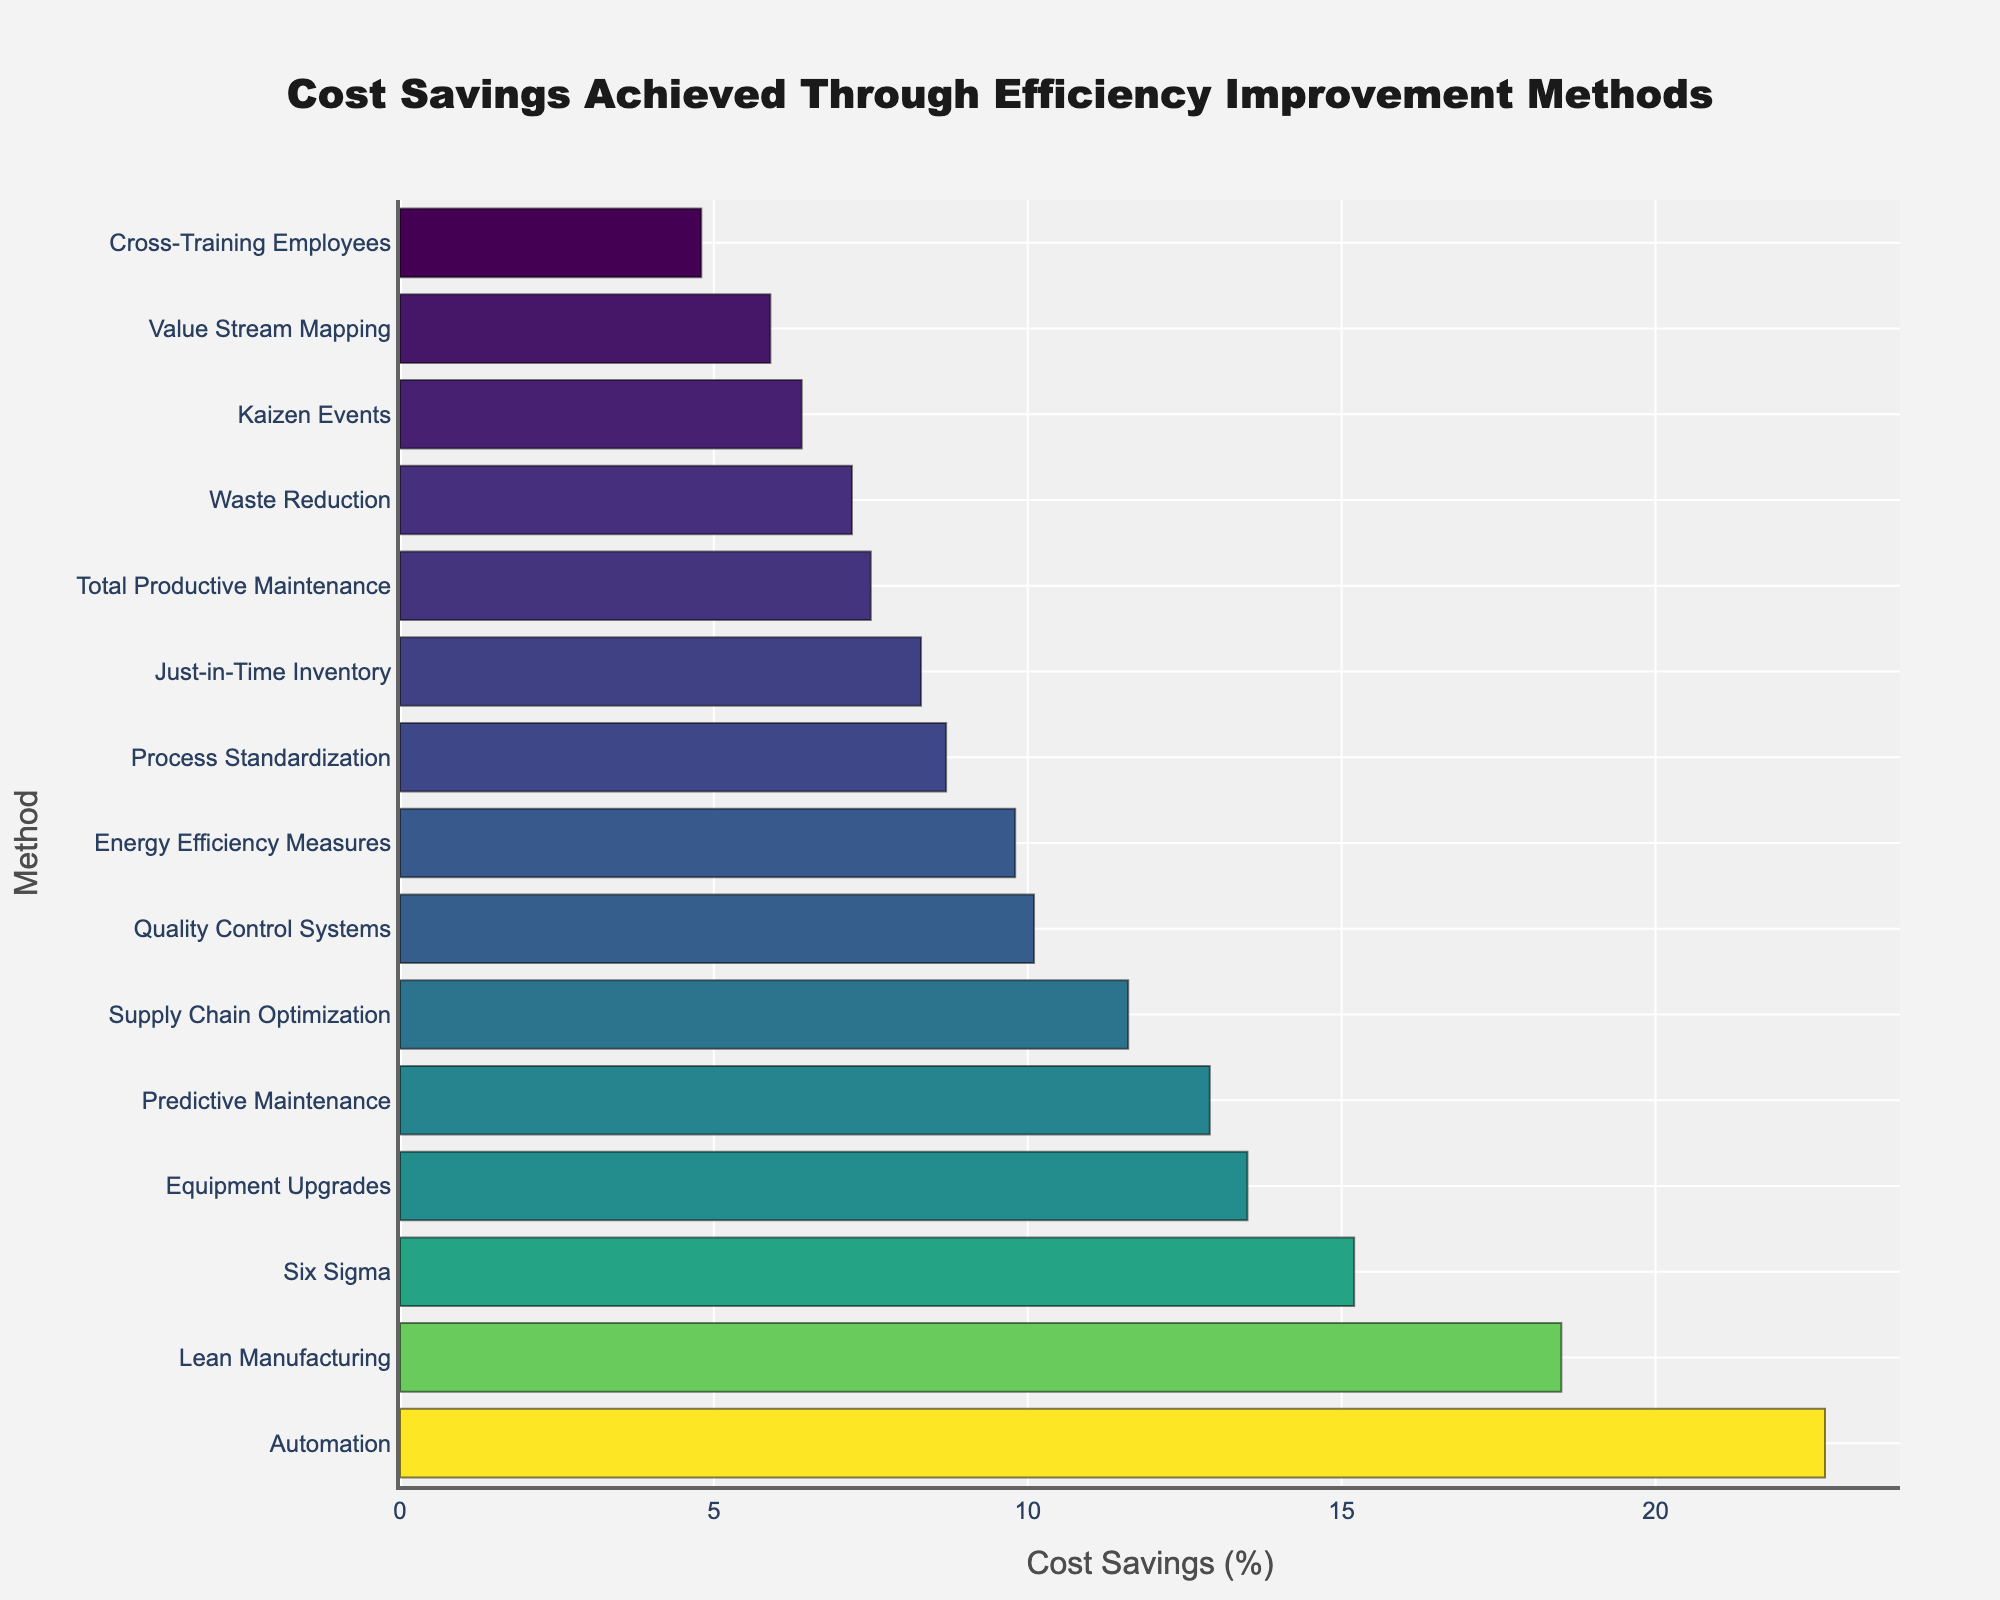Which method achieved the highest cost savings? The method that achieved the highest cost savings is the one with the longest bar in the chart, which is Automation with 22.7%.
Answer: Automation Which method achieved the lowest cost savings? The method that achieved the lowest cost savings is the one with the shortest bar in the chart, which is Cross-Training Employees with 4.8%.
Answer: Cross-Training Employees Which methods achieved cost savings greater than 10%? The methods with cost savings greater than 10% are those with bars that extend beyond the 10% mark on the x-axis. These methods are Lean Manufacturing (18.5%), Six Sigma (15.2%), Automation (22.7%), Predictive Maintenance (12.9%), Quality Control Systems (10.1%), Equipment Upgrades (13.5%), and Supply Chain Optimization (11.6%).
Answer: Lean Manufacturing, Six Sigma, Automation, Predictive Maintenance, Quality Control Systems, Equipment Upgrades, Supply Chain Optimization Which method is directly below Automation in terms of cost savings? The method directly below Automation in the chart, indicating it is the next highest in cost savings, is Lean Manufacturing with 18.5%.
Answer: Lean Manufacturing How much more cost savings percentage did Automation achieve compared to Six Sigma? Automation achieved 22.7% while Six Sigma achieved 15.2%. The difference is 22.7% - 15.2% = 7.5%.
Answer: 7.5% What is the combined cost savings percentage of Lean Manufacturing and Predictive Maintenance? The combined cost savings percentage is the sum of the individual percentages: Lean Manufacturing (18.5%) + Predictive Maintenance (12.9%) = 31.4%.
Answer: 31.4% Is the cost savings by Energy Efficiency Measures more than that by Just-in-Time Inventory? Energy Efficiency Measures achieved 9.8% while Just-in-Time Inventory achieved 8.3%. 9.8% is greater than 8.3%, so yes, Energy Efficiency Measures saved more.
Answer: Yes Which methods fall between 5% and 10% cost savings? The methods with bars extending between 5% and 10% on the x-axis are Energy Efficiency Measures (9.8%), Supply Chain Optimization (11.6%), Just-in-Time Inventory (8.3%), Total Productive Maintenance (7.5%), Kaizen Events (6.4%), Value Stream Mapping (5.9%), Waste Reduction (7.2%), and Process Standardization (8.7%).
Answer: Energy Efficiency Measures, Just-in-Time Inventory, Total Productive Maintenance, Kaizen Events, Value Stream Mapping, Waste Reduction, Process Standardization 